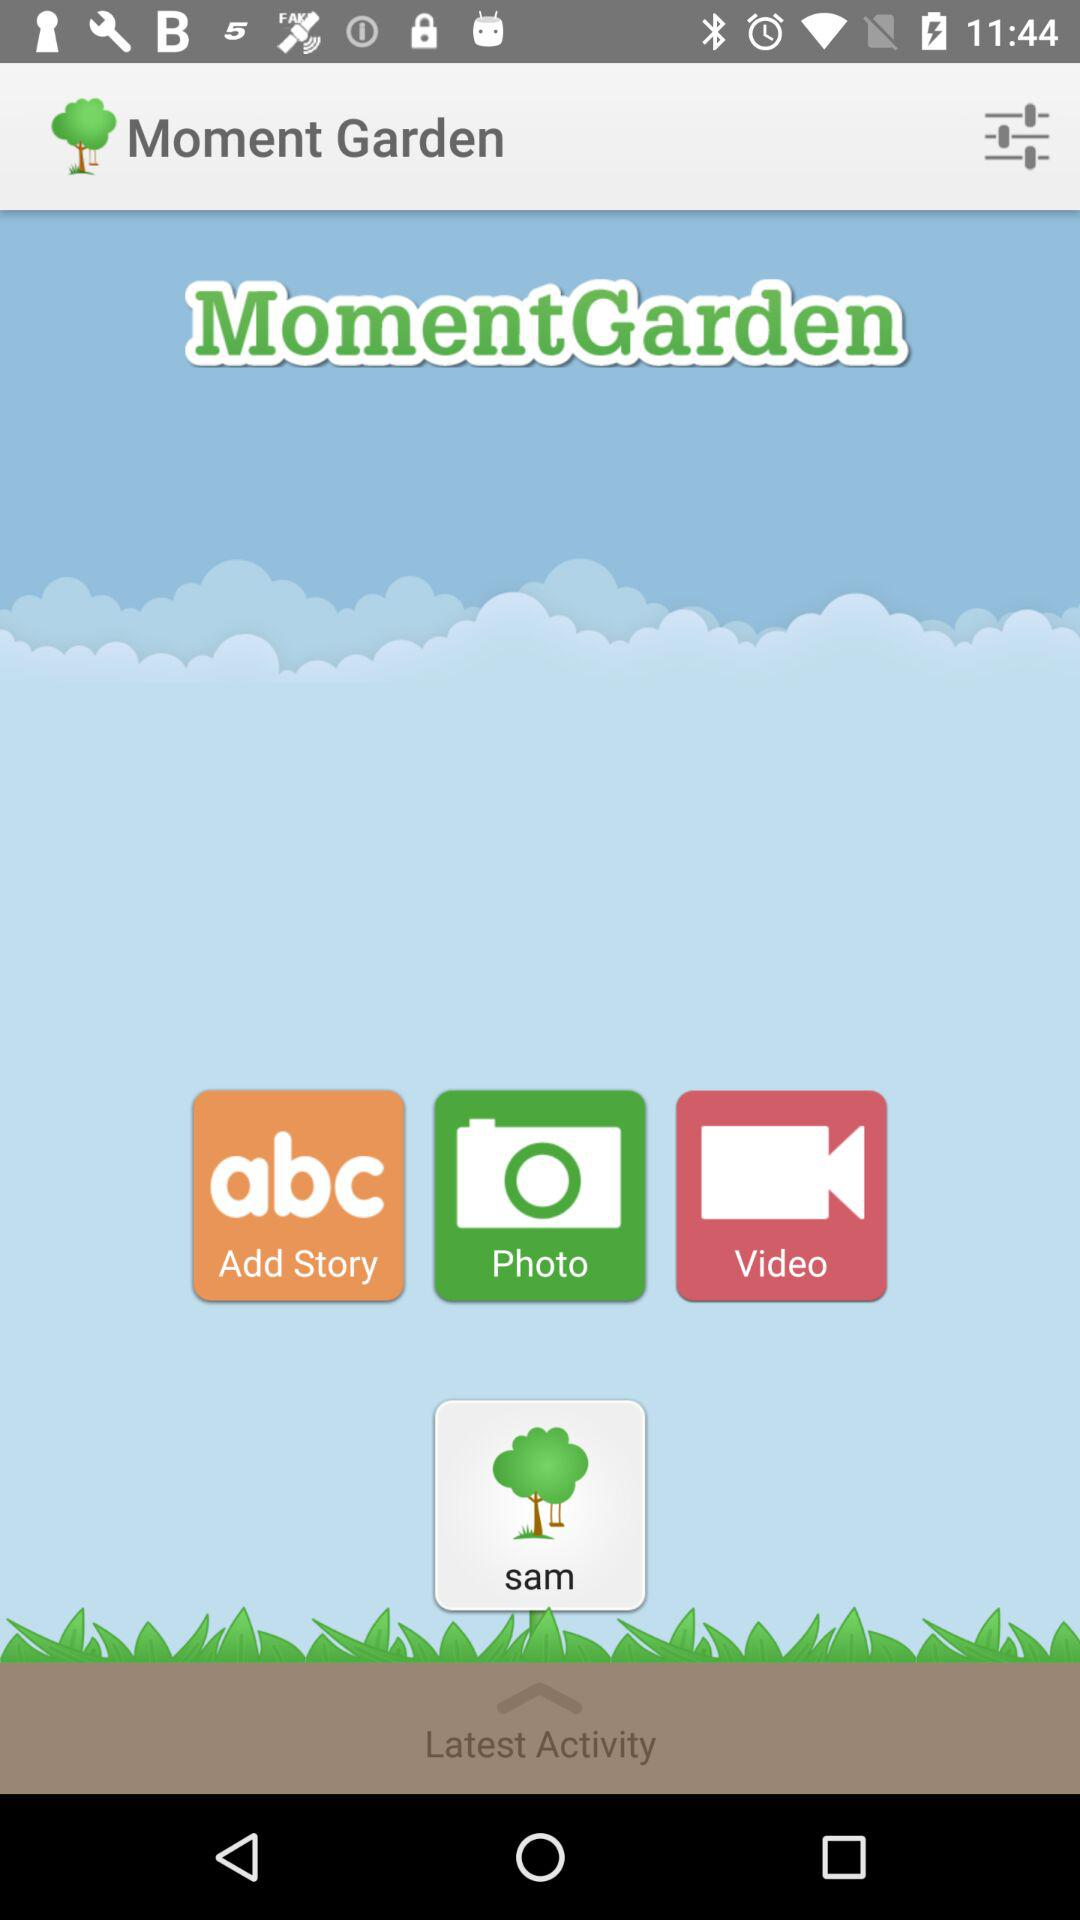What is the user name? The user name is Sam. 